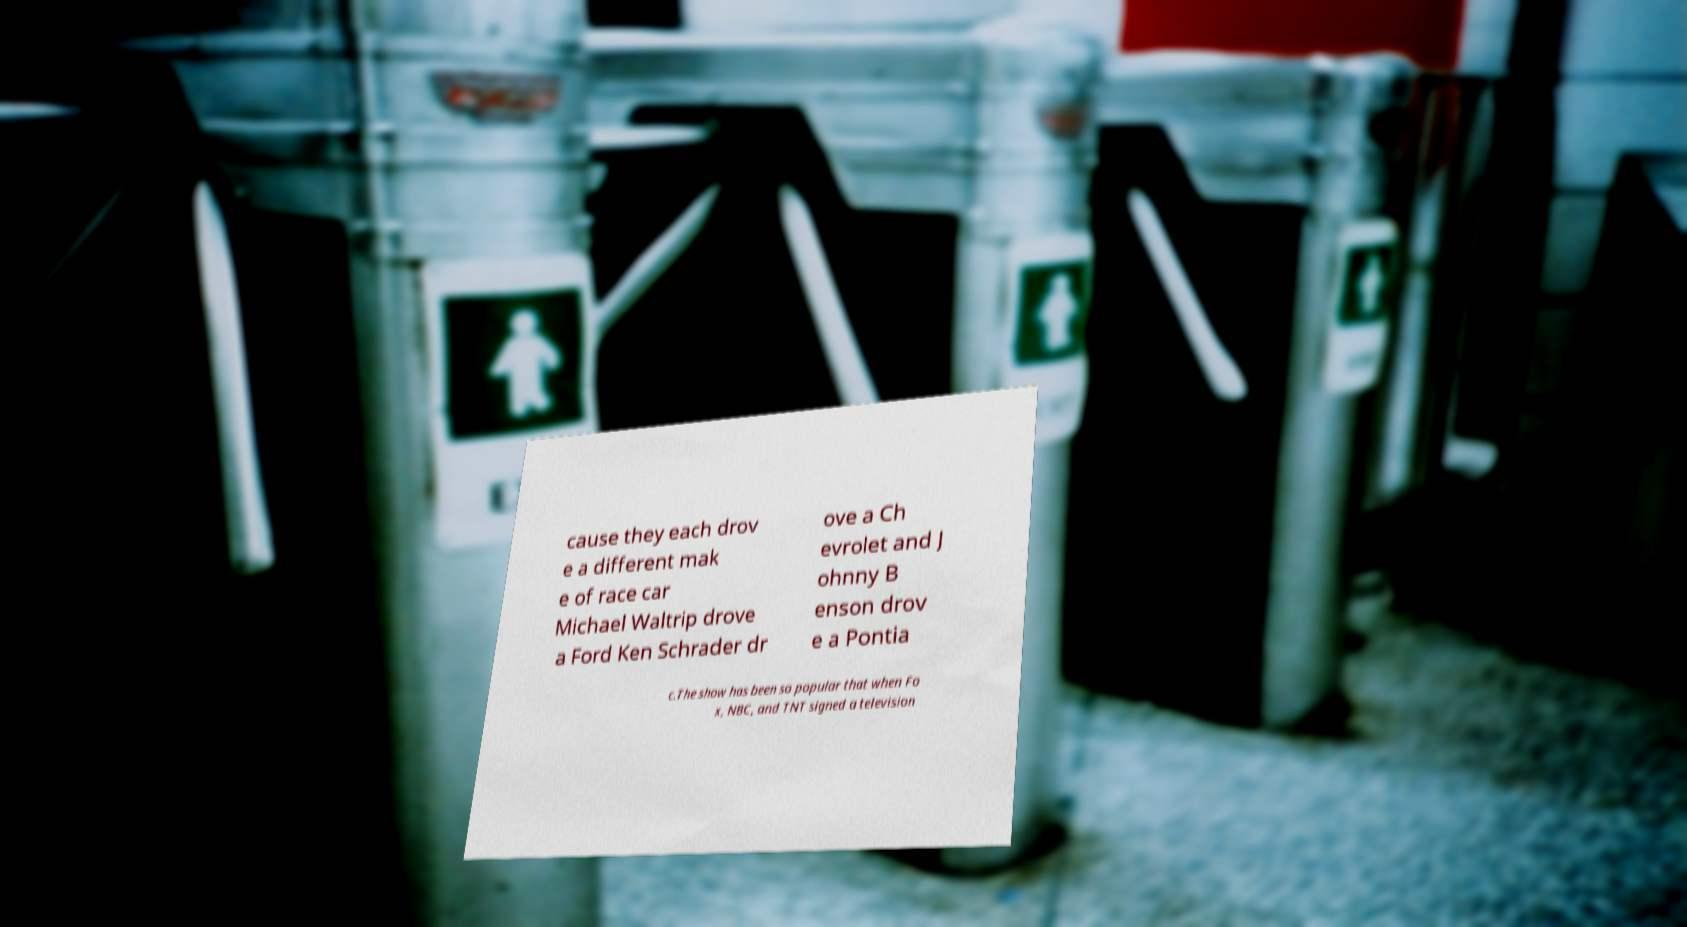I need the written content from this picture converted into text. Can you do that? cause they each drov e a different mak e of race car Michael Waltrip drove a Ford Ken Schrader dr ove a Ch evrolet and J ohnny B enson drov e a Pontia c.The show has been so popular that when Fo x, NBC, and TNT signed a television 